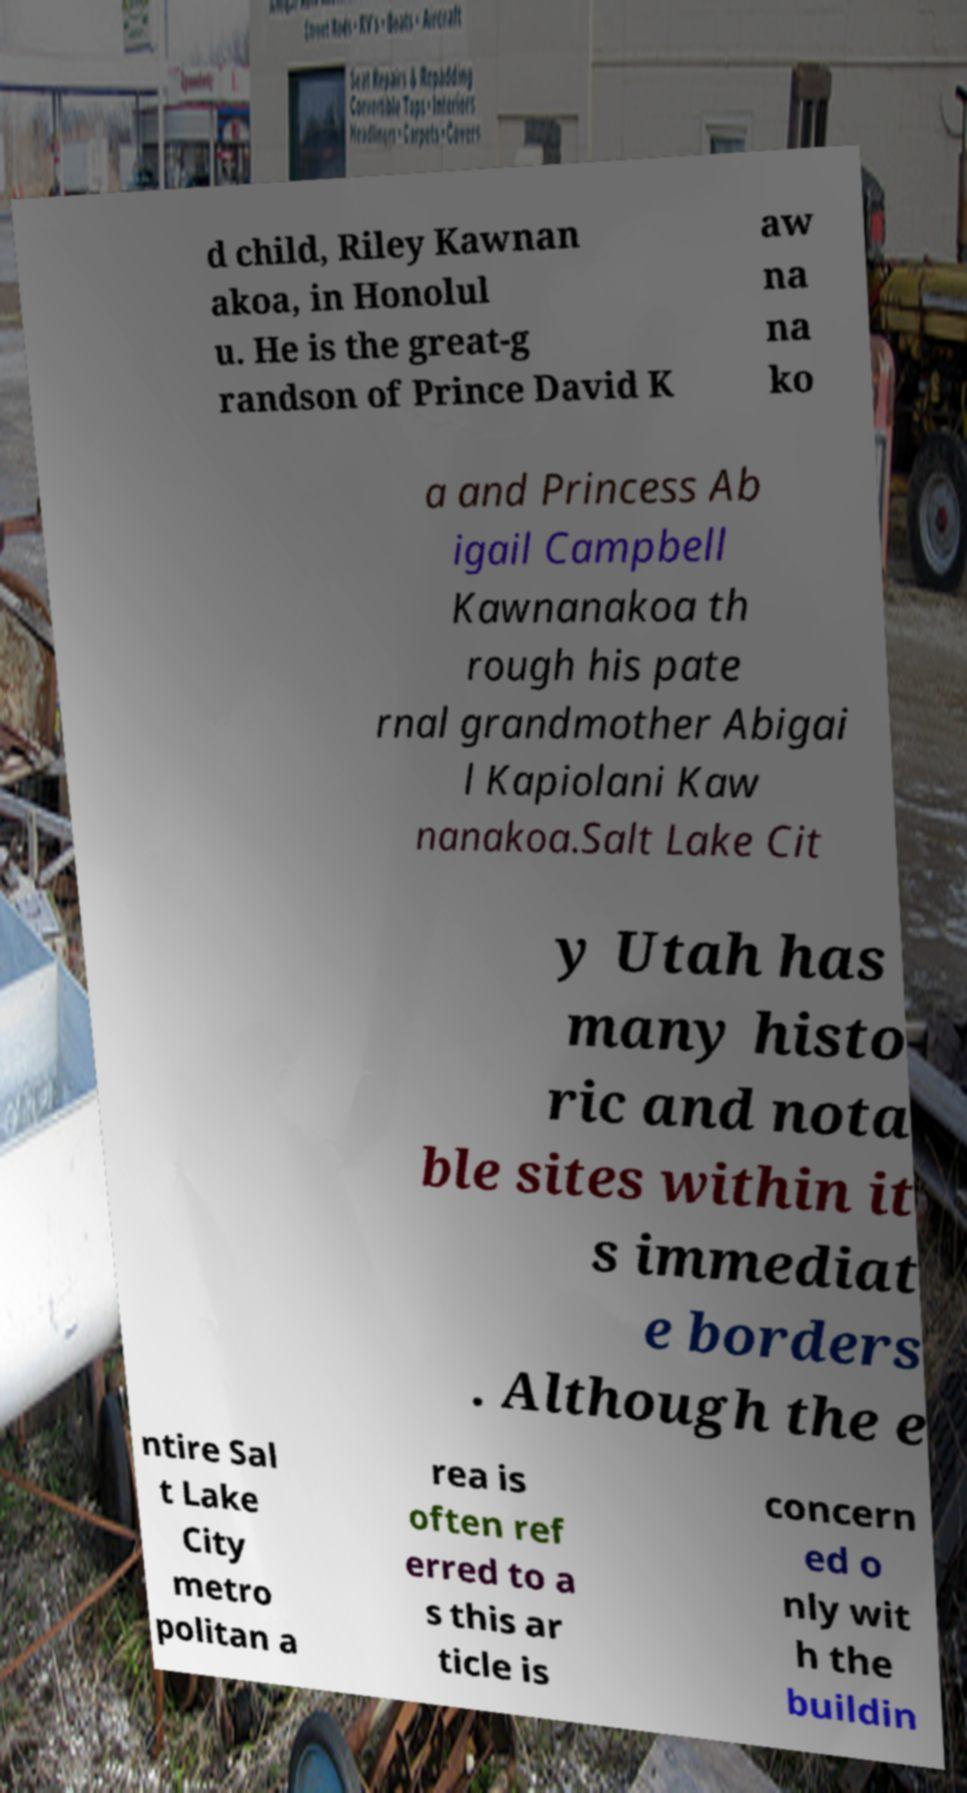Could you assist in decoding the text presented in this image and type it out clearly? d child, Riley Kawnan akoa, in Honolul u. He is the great-g randson of Prince David K aw na na ko a and Princess Ab igail Campbell Kawnanakoa th rough his pate rnal grandmother Abigai l Kapiolani Kaw nanakoa.Salt Lake Cit y Utah has many histo ric and nota ble sites within it s immediat e borders . Although the e ntire Sal t Lake City metro politan a rea is often ref erred to a s this ar ticle is concern ed o nly wit h the buildin 